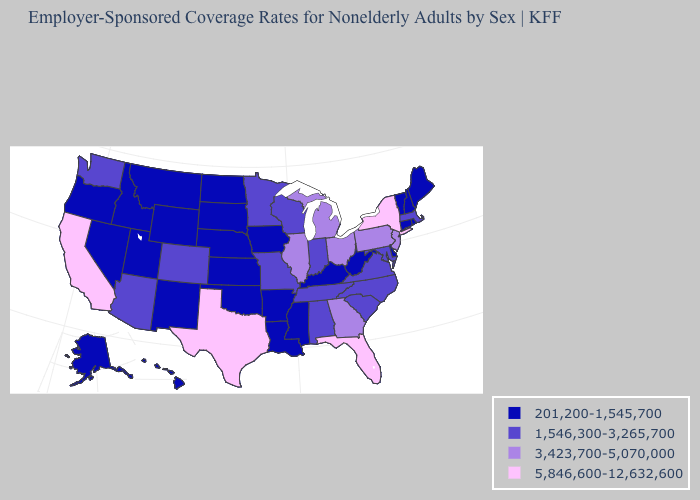Among the states that border New Mexico , which have the highest value?
Be succinct. Texas. What is the highest value in the USA?
Short answer required. 5,846,600-12,632,600. Name the states that have a value in the range 201,200-1,545,700?
Be succinct. Alaska, Arkansas, Connecticut, Delaware, Hawaii, Idaho, Iowa, Kansas, Kentucky, Louisiana, Maine, Mississippi, Montana, Nebraska, Nevada, New Hampshire, New Mexico, North Dakota, Oklahoma, Oregon, Rhode Island, South Dakota, Utah, Vermont, West Virginia, Wyoming. What is the value of New Hampshire?
Be succinct. 201,200-1,545,700. What is the highest value in the MidWest ?
Be succinct. 3,423,700-5,070,000. Which states have the lowest value in the USA?
Give a very brief answer. Alaska, Arkansas, Connecticut, Delaware, Hawaii, Idaho, Iowa, Kansas, Kentucky, Louisiana, Maine, Mississippi, Montana, Nebraska, Nevada, New Hampshire, New Mexico, North Dakota, Oklahoma, Oregon, Rhode Island, South Dakota, Utah, Vermont, West Virginia, Wyoming. Among the states that border Indiana , does Illinois have the highest value?
Be succinct. Yes. What is the lowest value in the USA?
Short answer required. 201,200-1,545,700. Does Oregon have the lowest value in the West?
Keep it brief. Yes. Name the states that have a value in the range 1,546,300-3,265,700?
Write a very short answer. Alabama, Arizona, Colorado, Indiana, Maryland, Massachusetts, Minnesota, Missouri, North Carolina, South Carolina, Tennessee, Virginia, Washington, Wisconsin. Which states have the lowest value in the USA?
Be succinct. Alaska, Arkansas, Connecticut, Delaware, Hawaii, Idaho, Iowa, Kansas, Kentucky, Louisiana, Maine, Mississippi, Montana, Nebraska, Nevada, New Hampshire, New Mexico, North Dakota, Oklahoma, Oregon, Rhode Island, South Dakota, Utah, Vermont, West Virginia, Wyoming. Does the first symbol in the legend represent the smallest category?
Answer briefly. Yes. What is the lowest value in the USA?
Quick response, please. 201,200-1,545,700. What is the lowest value in the South?
Answer briefly. 201,200-1,545,700. What is the lowest value in states that border Maine?
Short answer required. 201,200-1,545,700. 